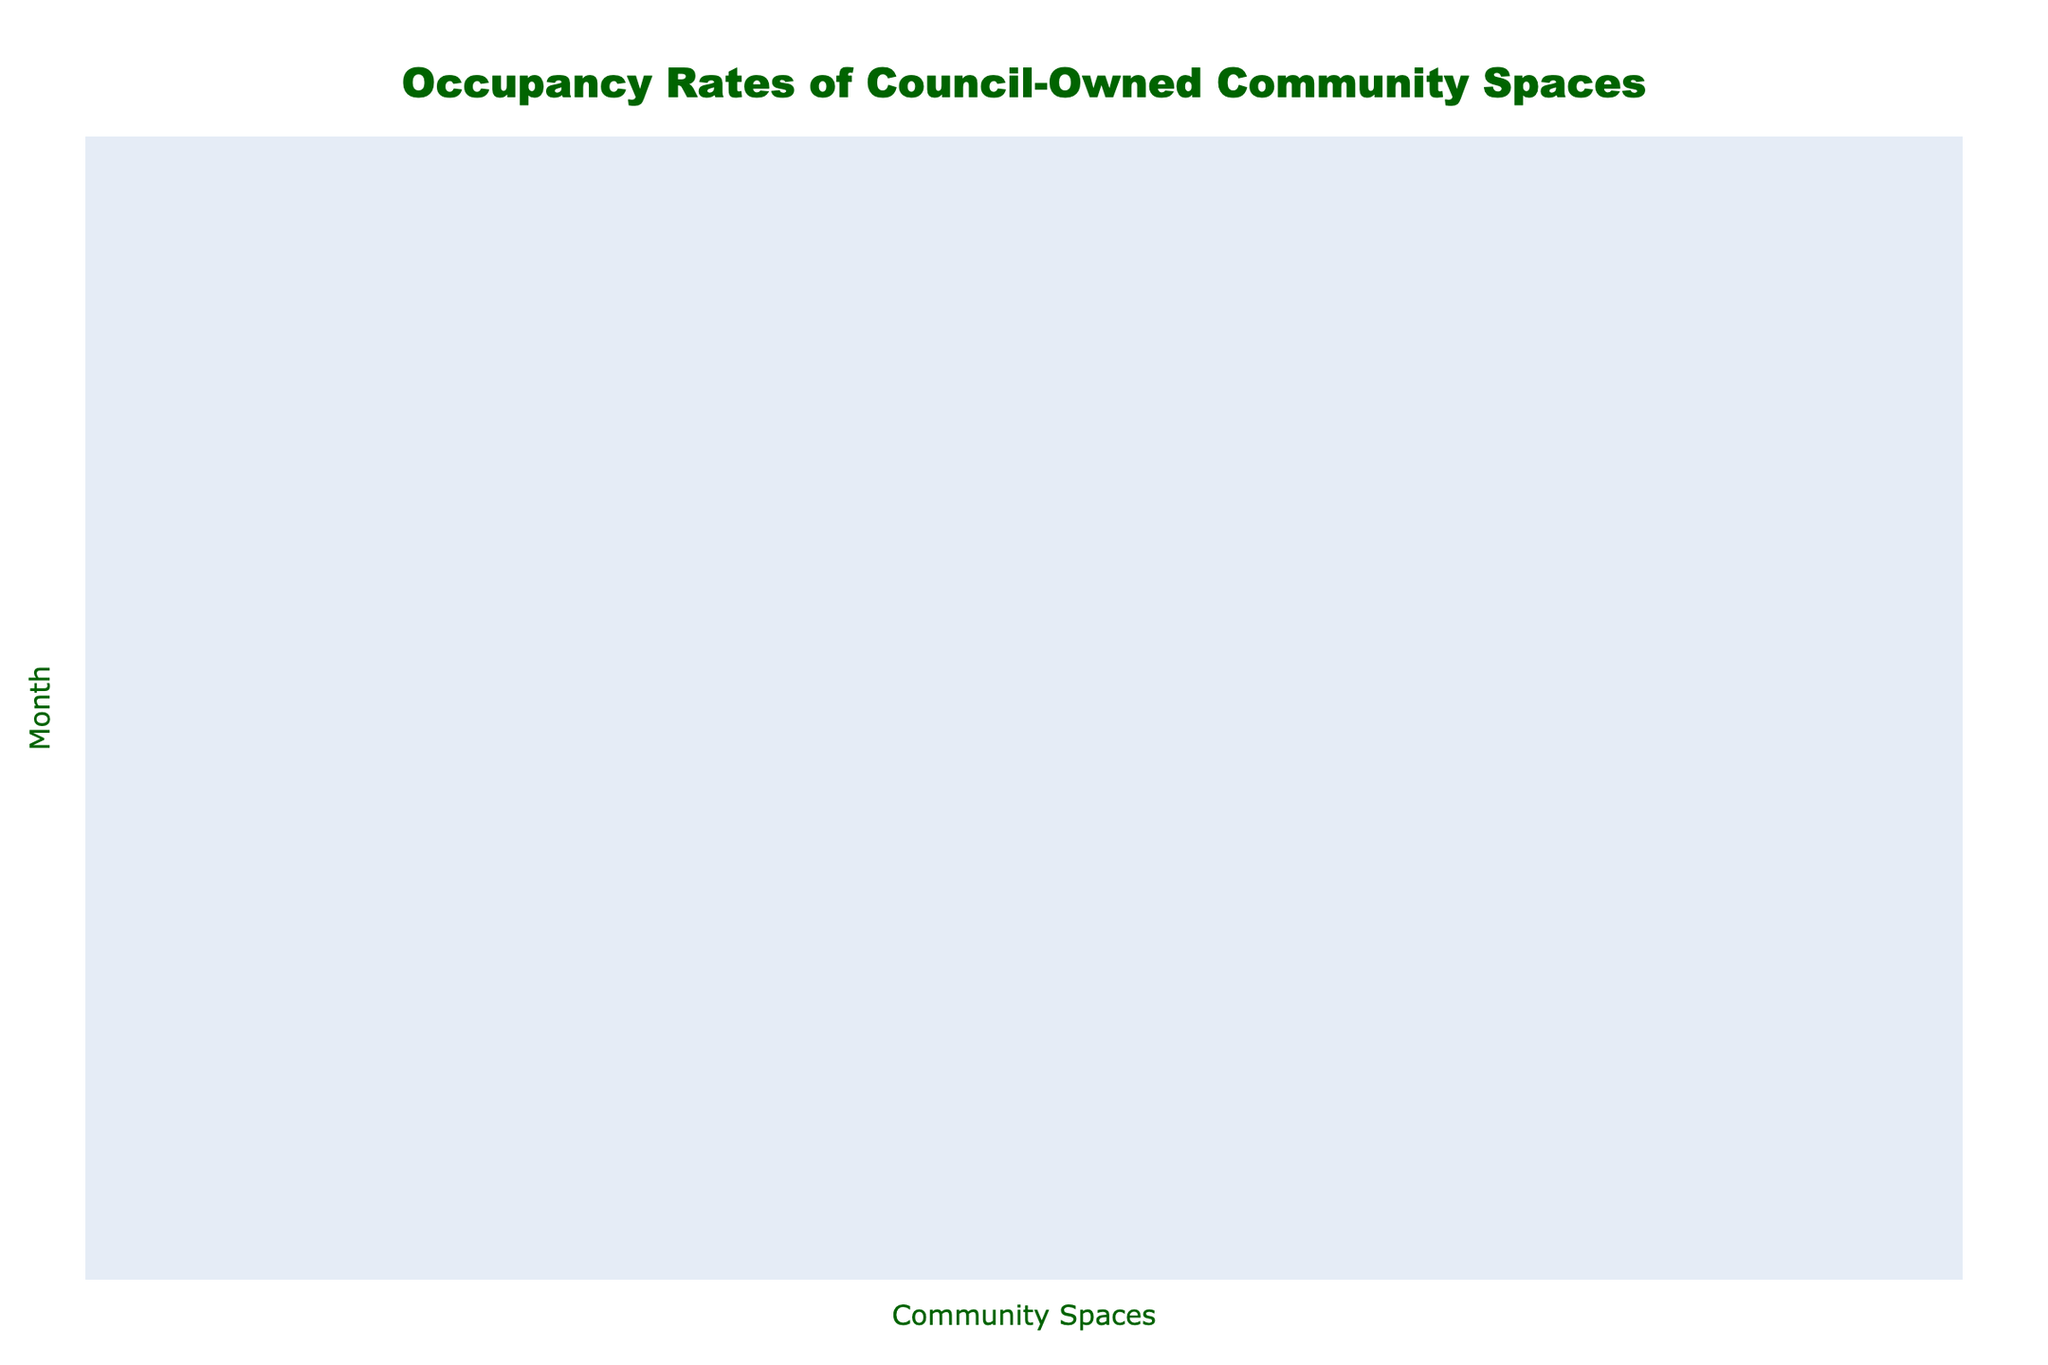What was the highest occupancy rate in the month of June? In June, the occupancy rates for each community space were reviewed, and the highest value recorded was 95% for Hackney Town Hall.
Answer: 95% In which month did Hackney Central Library have the lowest occupancy rate? By examining the occupancy rates for Hackney Central Library throughout the year, we find that February has the lowest rate at 75%.
Answer: February What is the average occupancy rate for Hoxton Hall for the entire year? The occupancy rates for Hoxton Hall across all months are collected: 58%, 62%, 65%, 68%, 70%, 73%, 71%, 69%, 72%, 66%, 63%, 60%. We sum these values to get 818% and divide by 12 months, resulting in an average of 68.17%.
Answer: 68.17% Did the occupancy rate for Stoke Newington Library increase or decrease from March to April? We compare the occupancy rates from March (73%) to April (75%) for Stoke Newington Library, noting that it increased from March to April.
Answer: Increase Which community space had the most consistent occupancy rates (least variation) throughout the year? By evaluating and comparing the occupancy rates of each community space across all months, we assess the range and standard deviation. After analysis, we find that Nightingale Community Centre had the least variation, indicating the most consistency.
Answer: Nightingale Community Centre In which month did Dalston CLR James Library achieve its peak occupancy rate? Reviewing the monthly rates, we find that Dalston CLR James Library reached its peak occupancy rate of 80% in June.
Answer: June What is the difference in occupancy rate between Hackney Town Hall and Nightingale Community Centre in October? For October, Hackney Town Hall has a rate of 89%, while Nightingale Community Centre has 57%. Thus, the difference is 89% - 57% = 32%.
Answer: 32% Which community space had the lowest occupancy rate at any point during the year? Upon examination of the occupancy rates, the lowest recorded was 45% for Urswick Community Centre in January.
Answer: Urswick Community Centre How many months did Hackney Town Hall have an occupancy rate above 90%? By counting the months with occupancy rates exceeding 90%, we find that January, April, May, and June all surpassed 90%, amounting to 4 months overall.
Answer: 4 months Was the occupancy rate for Shoreditch Library lower in August or September? Comparing the occupancy rates of Shoreditch Library, we see 74% in August and 77% in September; therefore, the rate was lower in August.
Answer: August 